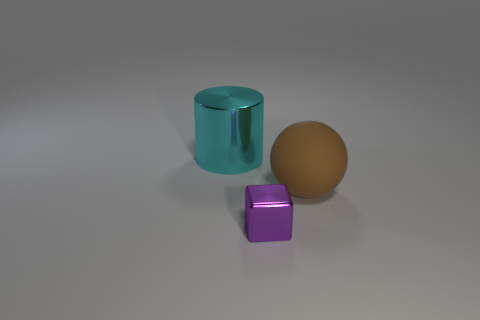Subtract 1 spheres. How many spheres are left? 0 Subtract all cylinders. How many objects are left? 2 Add 2 big blue rubber cubes. How many objects exist? 5 Subtract all purple metal objects. Subtract all purple cubes. How many objects are left? 1 Add 2 large metal cylinders. How many large metal cylinders are left? 3 Add 3 gray cylinders. How many gray cylinders exist? 3 Subtract 0 purple spheres. How many objects are left? 3 